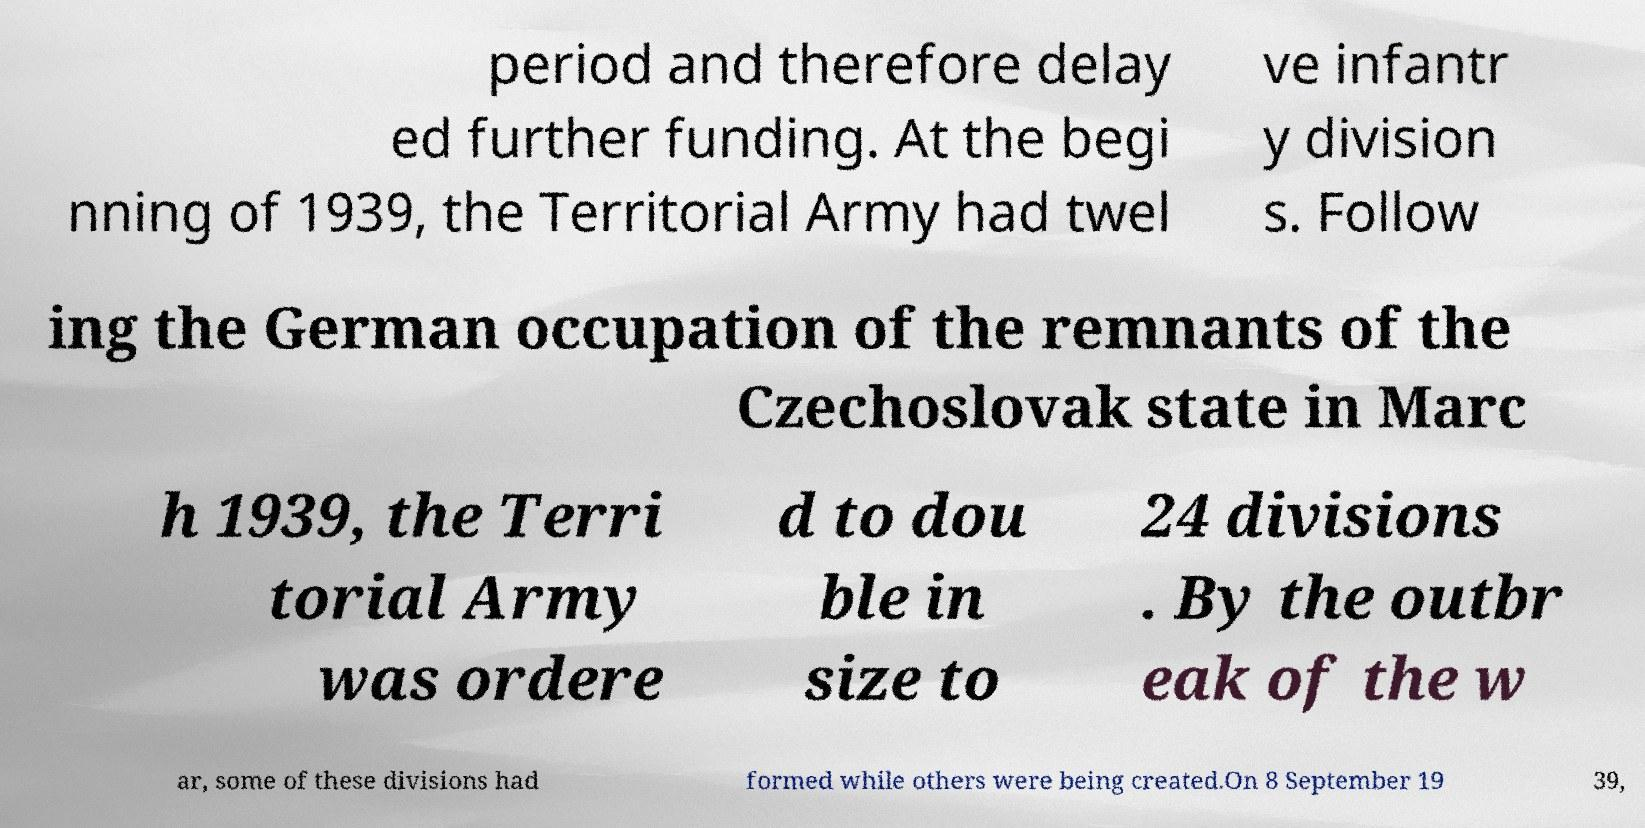Can you accurately transcribe the text from the provided image for me? period and therefore delay ed further funding. At the begi nning of 1939, the Territorial Army had twel ve infantr y division s. Follow ing the German occupation of the remnants of the Czechoslovak state in Marc h 1939, the Terri torial Army was ordere d to dou ble in size to 24 divisions . By the outbr eak of the w ar, some of these divisions had formed while others were being created.On 8 September 19 39, 